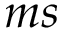<formula> <loc_0><loc_0><loc_500><loc_500>m s</formula> 